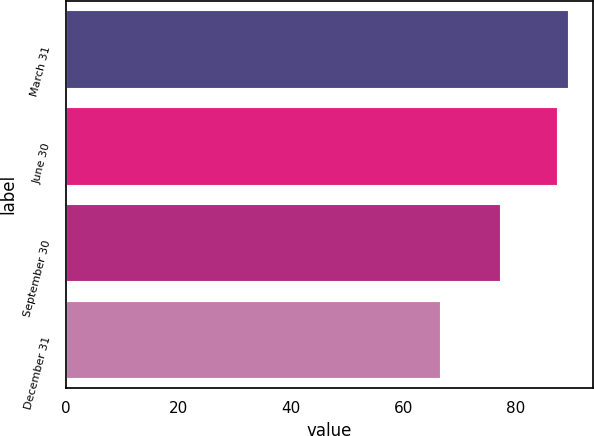Convert chart. <chart><loc_0><loc_0><loc_500><loc_500><bar_chart><fcel>March 31<fcel>June 30<fcel>September 30<fcel>December 31<nl><fcel>89.28<fcel>87.19<fcel>77.12<fcel>66.49<nl></chart> 